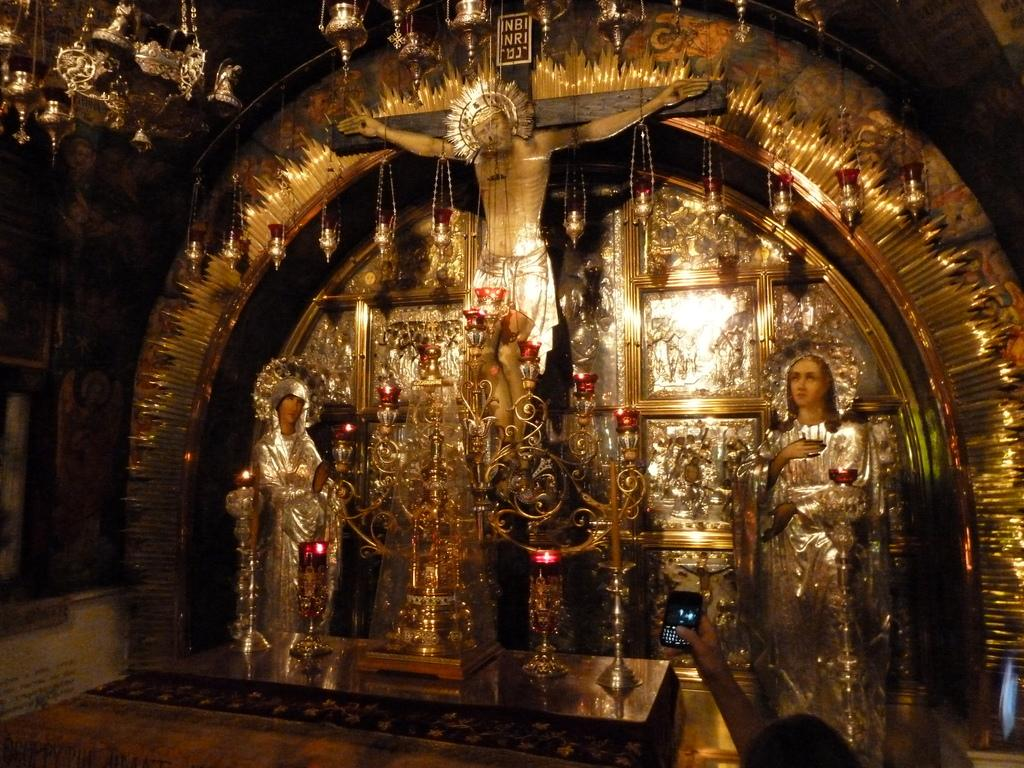What type of objects can be seen in the image? There are statues, a name board, oil lamps, and other objects in the image. Can you describe the statues in the image? The statues are not described in the provided facts, so we cannot provide specific details about them. What is the purpose of the name board in the image? The purpose of the name board is not mentioned in the provided facts, so we cannot determine its purpose. What type of lighting is present in the image? Oil lamps are present in the image, which suggests that the lighting is provided by oil lamps. What is the person in the image doing with the mobile? A person's hand is holding a mobile in the image, but the specific action or context is not mentioned in the provided facts. How many deer are present in the image? There are no deer present in the image; the provided facts mention statues, a name board, oil lamps, and other objects, but not deer. What government policy is being discussed in the image? There is no mention of any government policy or discussion in the provided facts, so we cannot determine if any such topic is present in the image. 